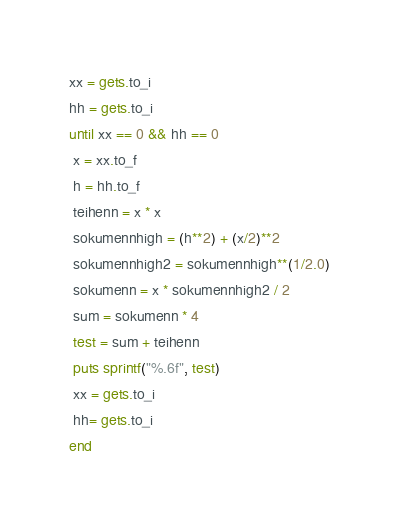<code> <loc_0><loc_0><loc_500><loc_500><_Ruby_>xx = gets.to_i
hh = gets.to_i
until xx == 0 && hh == 0
 x = xx.to_f
 h = hh.to_f
 teihenn = x * x
 sokumennhigh = (h**2) + (x/2)**2
 sokumennhigh2 = sokumennhigh**(1/2.0) 
 sokumenn = x * sokumennhigh2 / 2
 sum = sokumenn * 4
 test = sum + teihenn
 puts sprintf("%.6f", test)
 xx = gets.to_i
 hh= gets.to_i
end
</code> 